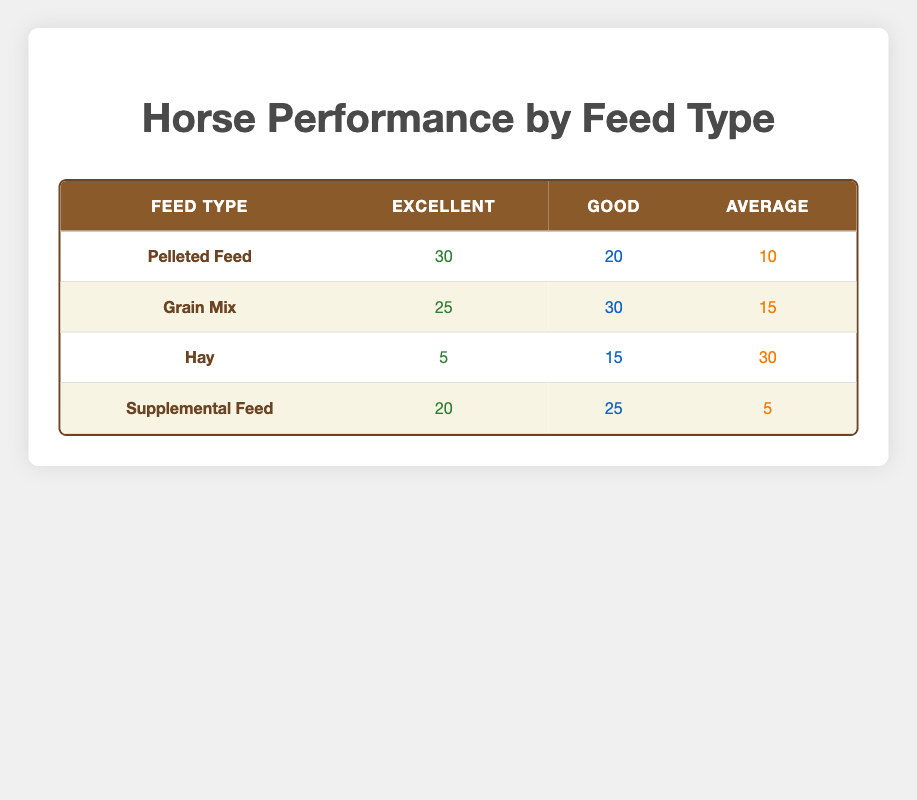What is the number of horses with "Excellent" performance on Pelleted Feed? The table shows that under "Pelleted Feed," the count for "Excellent" performance is 30.
Answer: 30 How many horses performed "Good" on Grain Mix? Referring to the table, the count of horses performing "Good" on Grain Mix is 30.
Answer: 30 Which feed type had the lowest count of horses performing "Excellent"? By examining the table, Hay has the lowest count of horses performing "Excellent," with a count of 5.
Answer: Hay What is the total number of horses that received Supplemental Feed? To find the total for Supplemental Feed, we sum the three counts: 20 (Excellent) + 25 (Good) + 5 (Average) = 50.
Answer: 50 Are more horses performing "Good" on Grain Mix than on Pelleted Feed? On Grain Mix, 30 horses performed "Good" while on Pelleted Feed, 20 horses performed "Good." Since 30 is greater than 20, the statement is true.
Answer: Yes What is the difference in the number of "Average" performing horses between Hay and Pelleted Feed? The count for "Average" performance on Hay is 30, and for Pelleted Feed, it is 10. The difference is 30 - 10 = 20.
Answer: 20 What percentage of horses on Hay achieved "Excellent" performance? The count for "Excellent" on Hay is 5. To calculate the percentage of horses with Excellent performance relative to the total on Hay (5 + 15 + 30 = 50), we use (5 / 50) * 100 = 10%.
Answer: 10% How many horses performed "Average" on Supplemental Feed? Under Supplemental Feed, the count for "Average" performance is 5, as directly shown in the table.
Answer: 5 Is it true that no horse performing "Excellent" received Hay? The table shows that 5 horses with Hay achieved "Excellent," so the statement is false.
Answer: No 